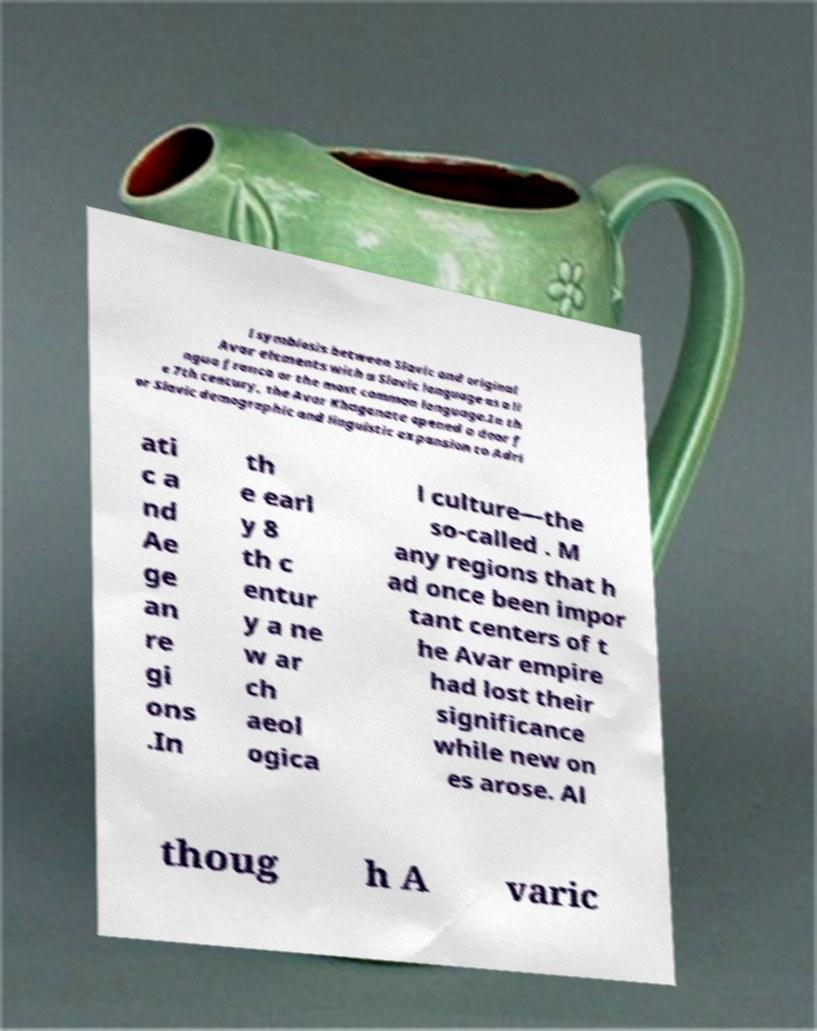Please read and relay the text visible in this image. What does it say? l symbiosis between Slavic and original Avar elements with a Slavic language as a li ngua franca or the most common language.In th e 7th century, the Avar Khaganate opened a door f or Slavic demographic and linguistic expansion to Adri ati c a nd Ae ge an re gi ons .In th e earl y 8 th c entur y a ne w ar ch aeol ogica l culture—the so-called . M any regions that h ad once been impor tant centers of t he Avar empire had lost their significance while new on es arose. Al thoug h A varic 